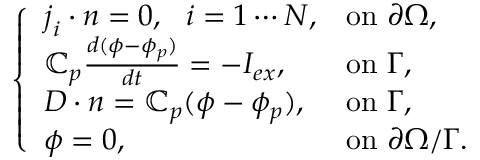Convert formula to latex. <formula><loc_0><loc_0><loc_500><loc_500>\left \{ \begin{array} { l l } { j _ { i } \cdot n = 0 , i = 1 \cdots N , } & { o n \partial \Omega , } \\ { \mathbb { C } _ { p } \frac { d ( \phi - \phi _ { p } ) } { d t } = - I _ { e x } , } & { o n \Gamma , } \\ { D \cdot n = \mathbb { C } _ { p } ( \phi - \phi _ { p } ) , } & { o n \Gamma , } \\ { \phi = 0 , } & { o n \partial \Omega / \Gamma . } \end{array}</formula> 